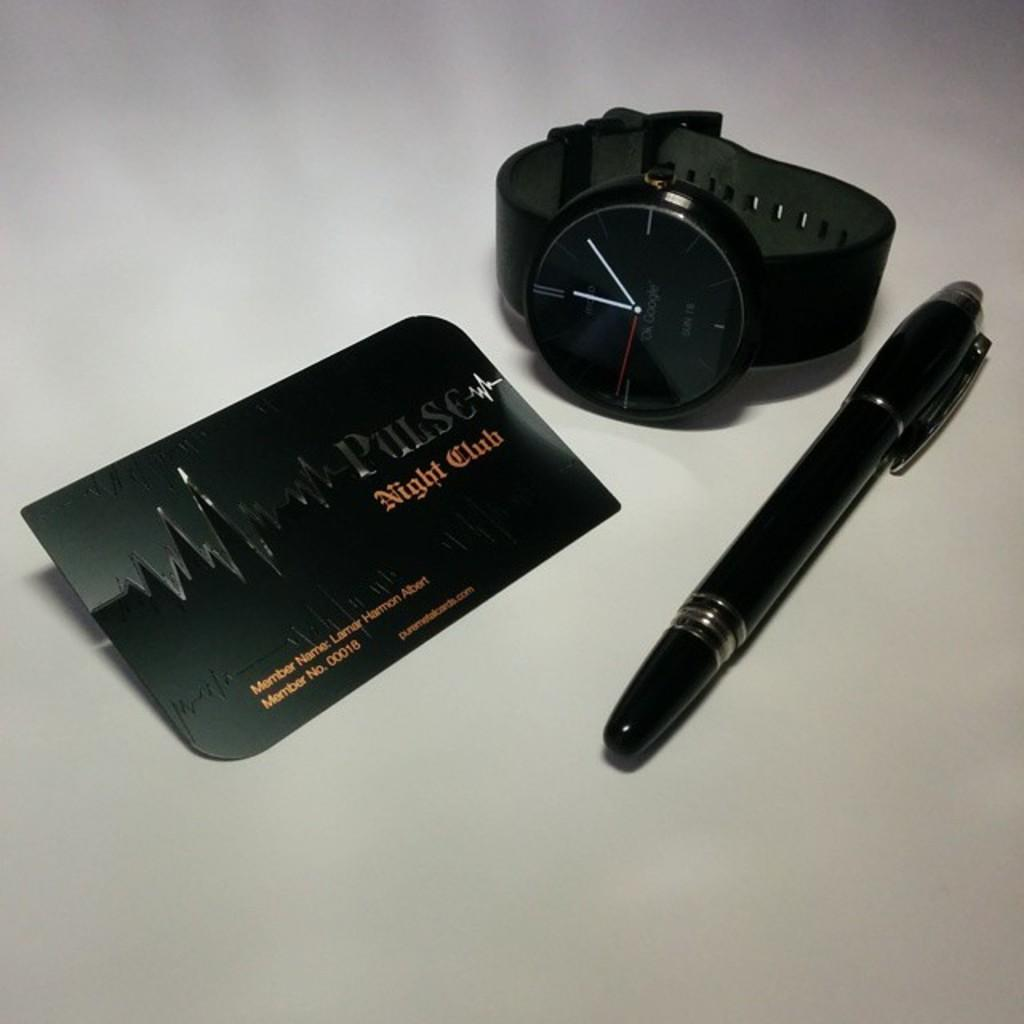What type of accessory is visible in the image? There is a wrist watch in the image. What is the color of the wrist watch? The wrist watch is black in color. What other items can be seen in the image? There is a pen and a card in the image. What is the color of the pen and the card? The pen and the card are black in color. What is the background color of the image? The background of the image is white. What type of winter clothing is visible in the image? There is no winter clothing present in the image; it features a wrist watch, a pen, a card, and a white background. Are there any police officers visible in the image? There are no police officers present in the image. 